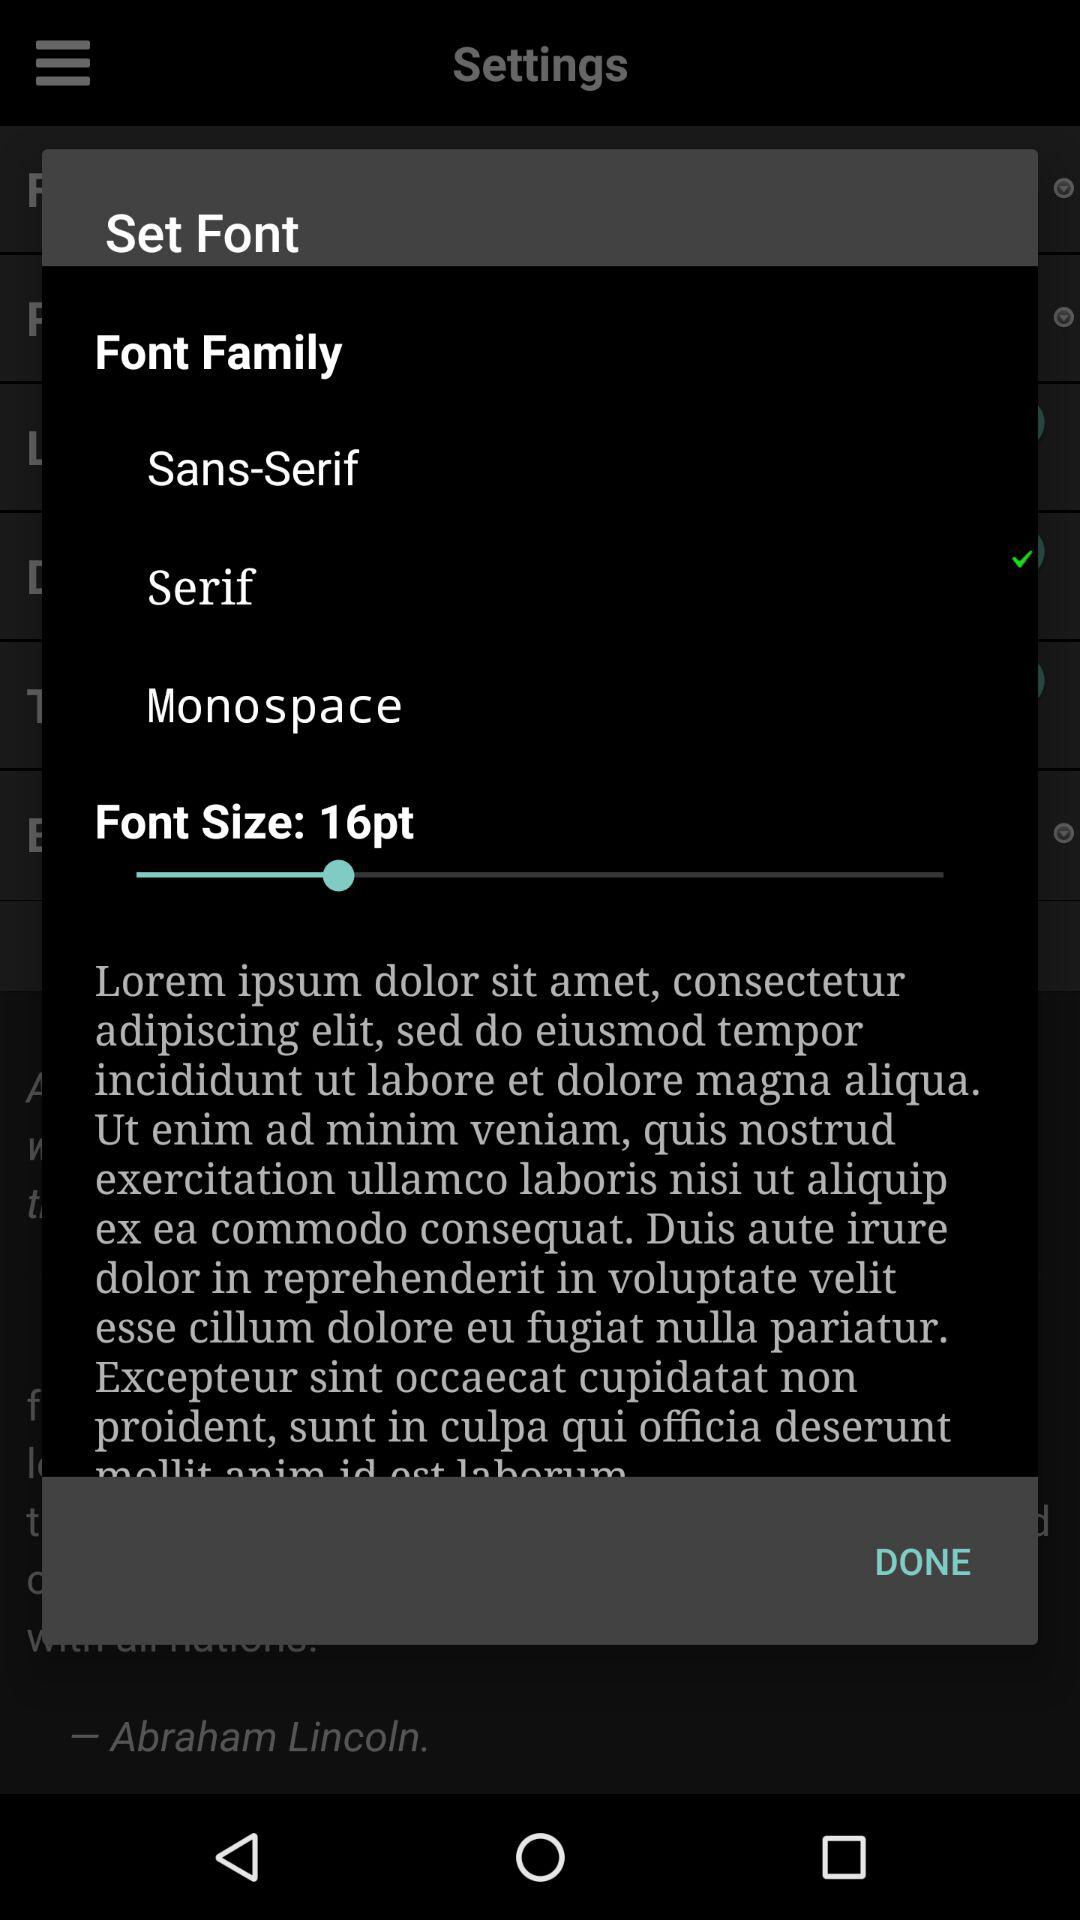What is the font size? The font size is 16 pt. 